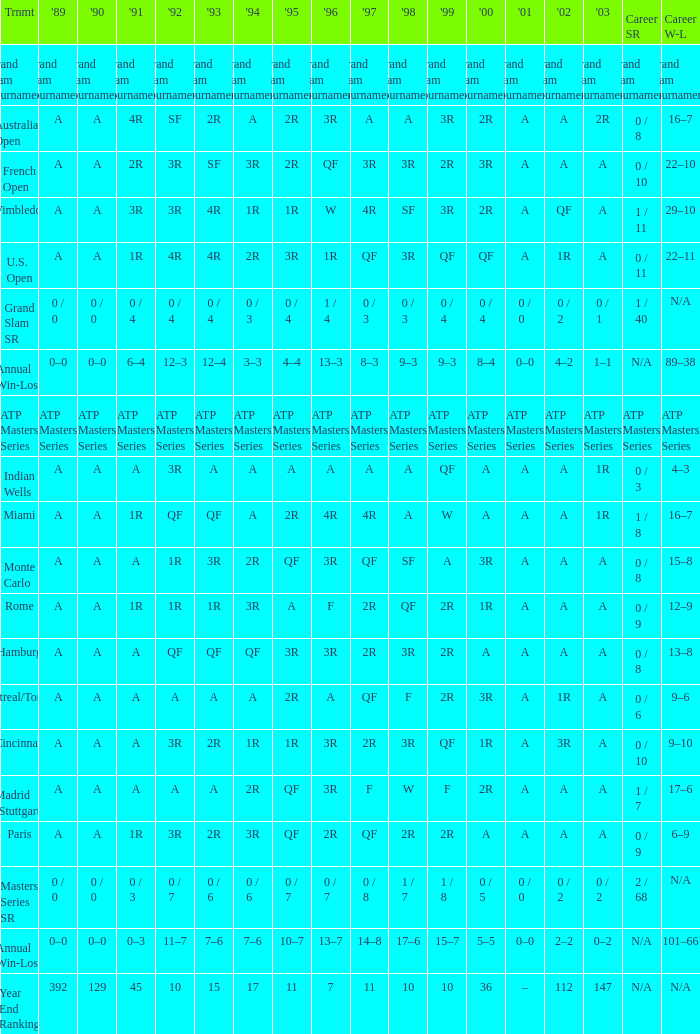What is the value in 1997 when the value in 1989 is A, 1995 is QF, 1996 is 3R and the career SR is 0 / 8? QF. 